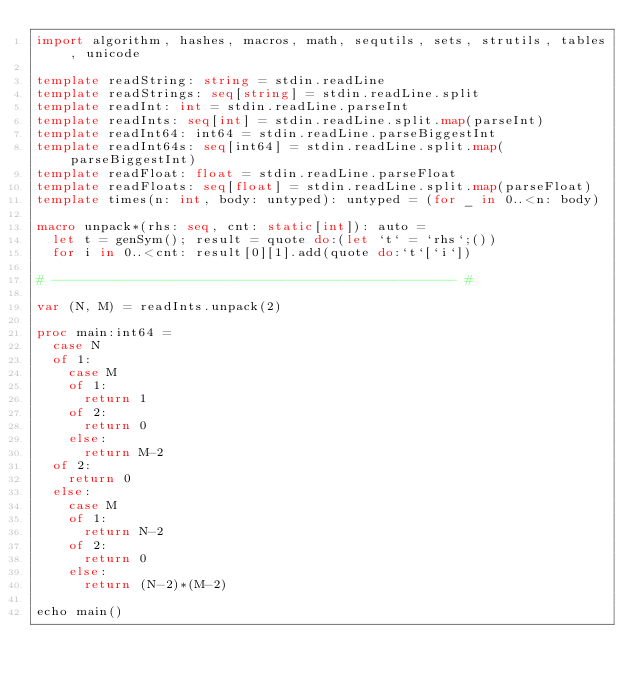Convert code to text. <code><loc_0><loc_0><loc_500><loc_500><_Nim_>import algorithm, hashes, macros, math, sequtils, sets, strutils, tables, unicode

template readString: string = stdin.readLine
template readStrings: seq[string] = stdin.readLine.split
template readInt: int = stdin.readLine.parseInt
template readInts: seq[int] = stdin.readLine.split.map(parseInt)
template readInt64: int64 = stdin.readLine.parseBiggestInt
template readInt64s: seq[int64] = stdin.readLine.split.map(parseBiggestInt)
template readFloat: float = stdin.readLine.parseFloat
template readFloats: seq[float] = stdin.readLine.split.map(parseFloat)
template times(n: int, body: untyped): untyped = (for _ in 0..<n: body)

macro unpack*(rhs: seq, cnt: static[int]): auto =
  let t = genSym(); result = quote do:(let `t` = `rhs`;())
  for i in 0..<cnt: result[0][1].add(quote do:`t`[`i`])

# --------------------------------------------------- #

var (N, M) = readInts.unpack(2)

proc main:int64 =
  case N
  of 1:
    case M
    of 1:
      return 1
    of 2:
      return 0
    else:
      return M-2
  of 2:
    return 0
  else:
    case M
    of 1:
      return N-2
    of 2:
      return 0
    else:
      return (N-2)*(M-2)

echo main()</code> 